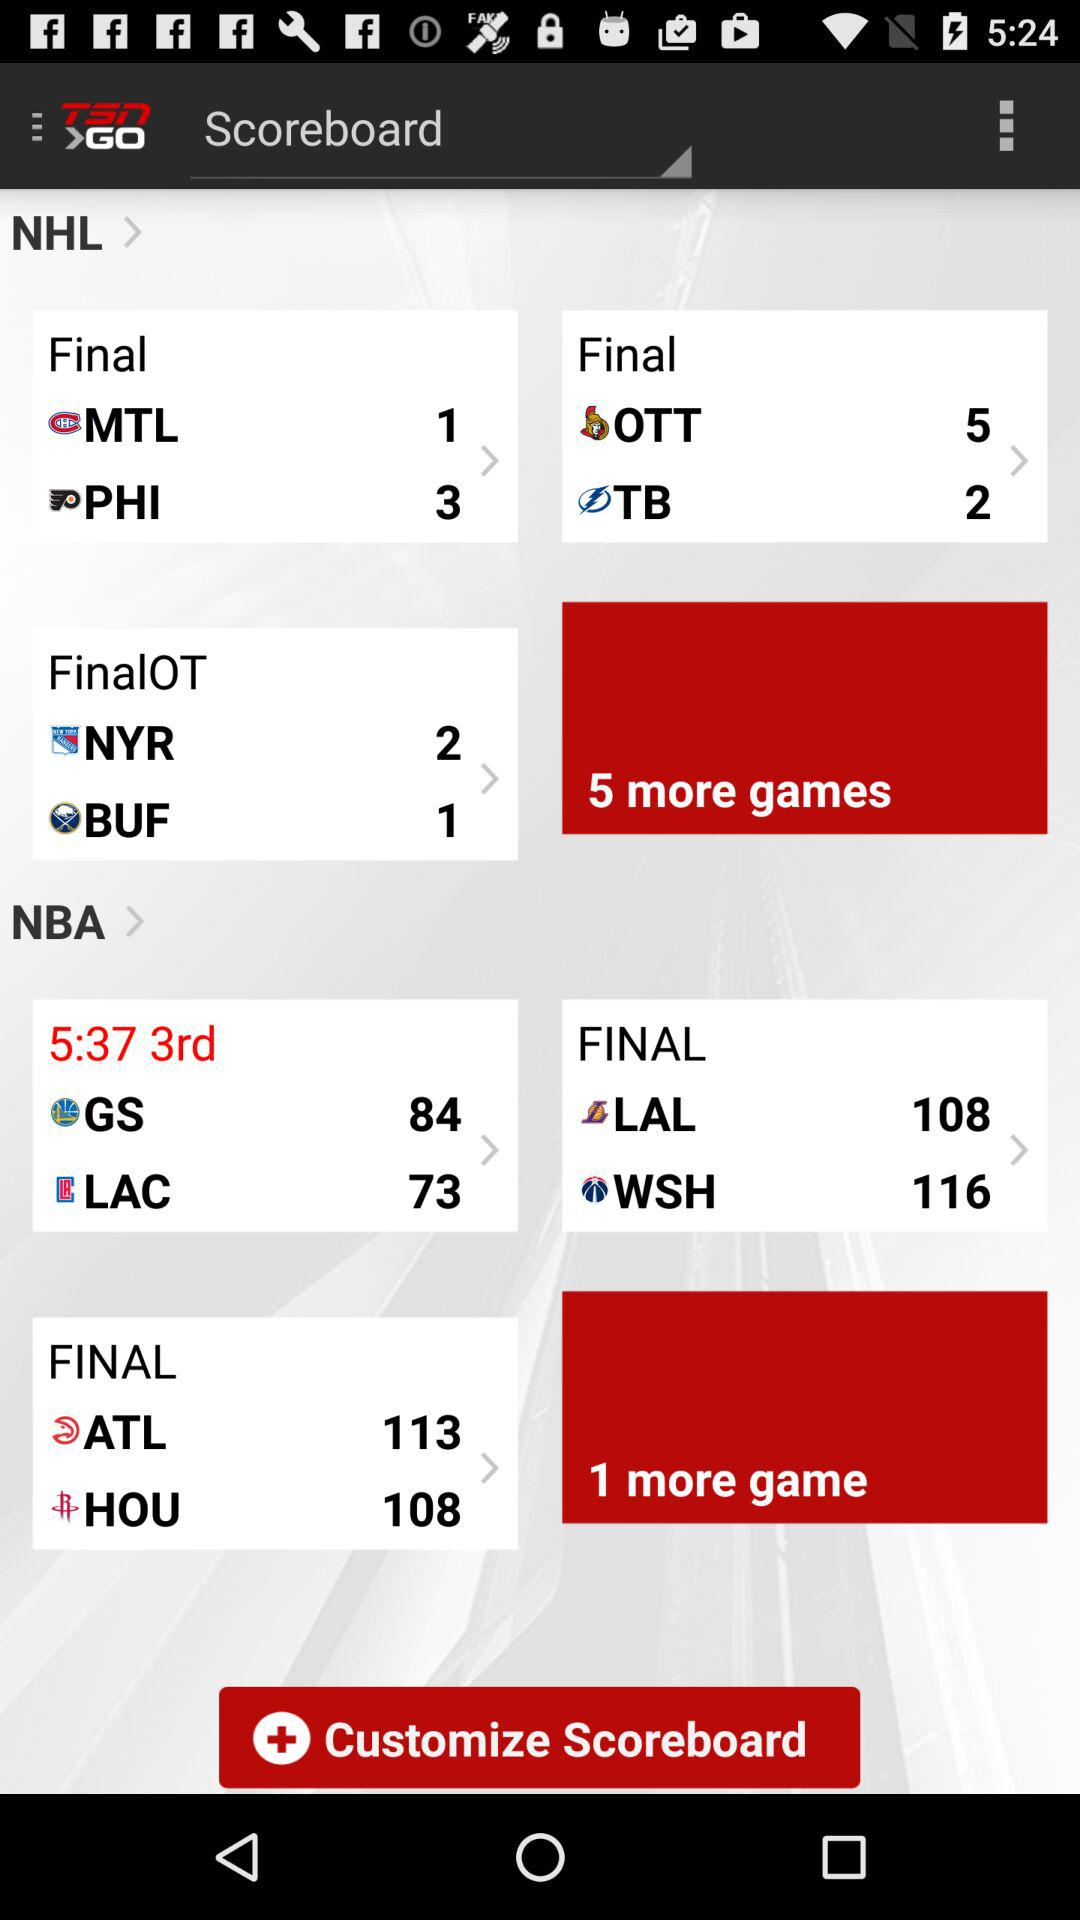How many more points does Atlanta have than Houston?
Answer the question using a single word or phrase. 5 